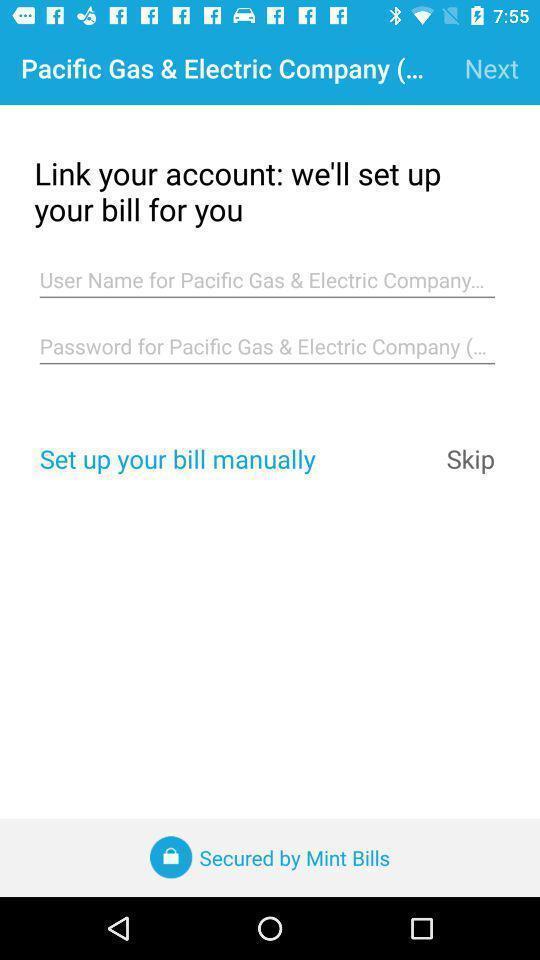Provide a detailed account of this screenshot. Screen shows details of bill. 